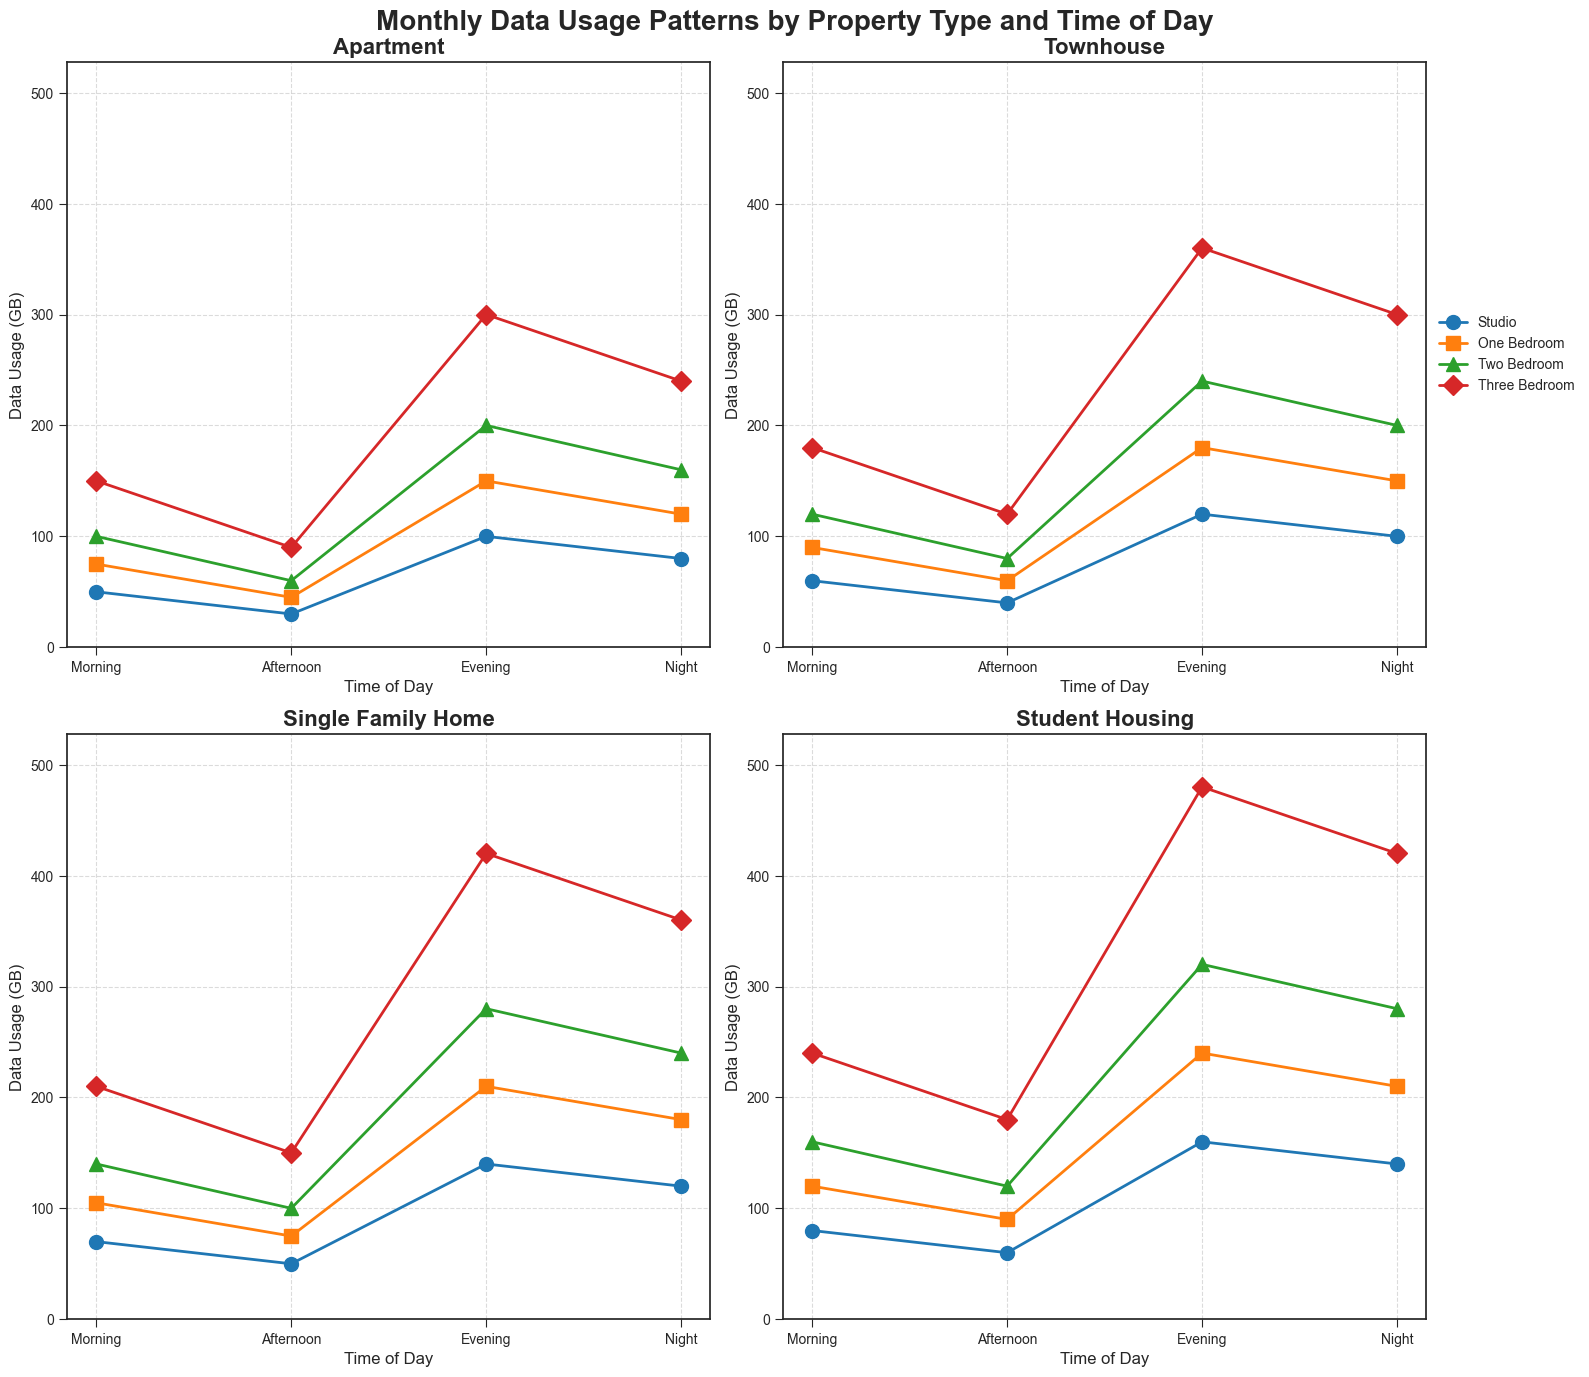What's the peak data usage in Three Bedroom apartments across the day? The Three Bedroom data usage in Apartments (subplots) is recorded at various times of the day. The peak value can be seen in the Evening, where the value is highest.
Answer: 300 GB At what time of day do Townhouses have the lowest data usage for One Bedroom units? Observing the subplot for Townhouses, the One Bedroom line shows the lowest data usage value in the Afternoon.
Answer: Afternoon How does data usage for Two Bedroom units in Student Housing compare between Morning and Night? In the Student Housing subplot, the Two Bedroom line shows higher data usage at night compared to the morning. Specifically, the Morning data usage is 160 GB, whereas the Night data usage is 280 GB.
Answer: Higher at Night Which property type shows the highest data usage for Studio units in the Evening? Comparing the Evening data for Studio units across all subplots, Student Housing has the highest value with 160 GB.
Answer: Student Housing What's the total data usage for Three Bedroom units in Single Family Homes throughout the entire day? Summing up the data usage values for Three Bedroom units in Single Family Homes across all times of day: Morning (210 GB) + Afternoon (150 GB) + Evening (420 GB) + Night (360 GB) = 1140 GB.
Answer: 1140 GB Which property type exhibits consistently higher data usage for all Bedroom types in the Evening? By checking the Evening data lines in all subplots, Student Housing consistently shows higher values for all Bedroom types (Studio 160 GB, One Bedroom 240 GB, Two Bedroom 320 GB, Three Bedroom 480 GB).
Answer: Student Housing What's the average data usage for One Bedroom units in Apartments during the Afternoon and Evening? Average usage is calculated as (Afternoon value 45 + Evening value 150) / 2 = 97.5 GB.
Answer: 97.5 GB How much more data do Two Bedroom units in Townhouses use in the Evening compared to the Afternoon? The difference in data usage between Evening (240 GB) and Afternoon (80 GB) for Two Bedroom units in Townhouses is calculated as 240 - 80 = 160 GB.
Answer: 160 GB In which property type and time of day is the data usage for Studio units exactly twice its Morning value? Observing all the subplots, the Student Housing property type shows the Studio units’ Evening data usage (160 GB) is exactly twice its Morning value (80 GB).
Answer: Student Housing, Evening 